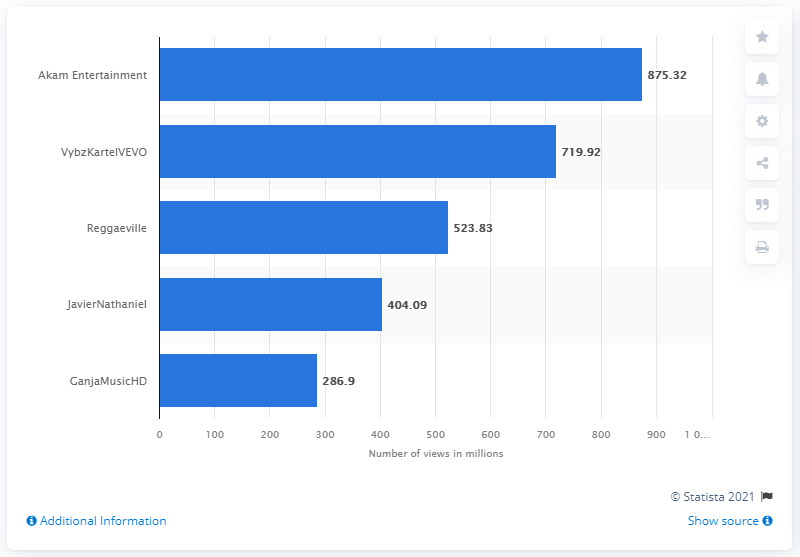Outline some significant characteristics in this image. As of March 2021, Reggaeville had 719.92 views. According to the information available as of March 2021, the YouTube channel with the most views in Jamaica is named Akam Entertainment. As of March 2021, Akam Entertainment had a total of 875.32 views in Jamaica. 